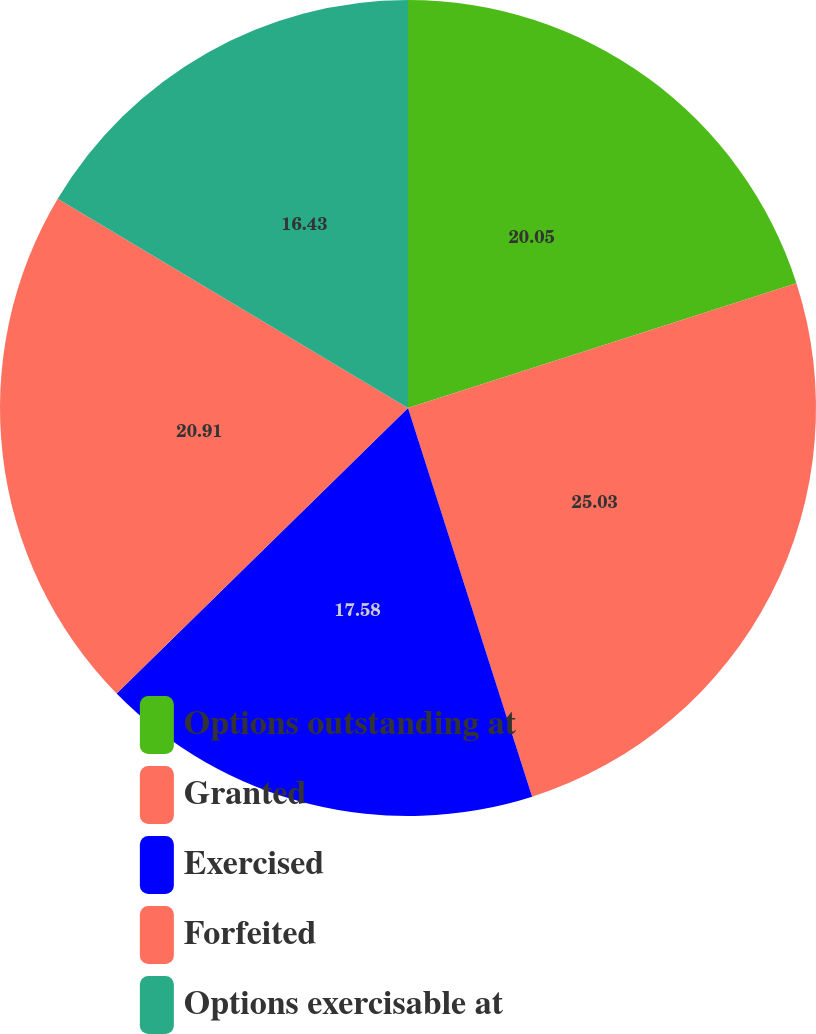Convert chart to OTSL. <chart><loc_0><loc_0><loc_500><loc_500><pie_chart><fcel>Options outstanding at<fcel>Granted<fcel>Exercised<fcel>Forfeited<fcel>Options exercisable at<nl><fcel>20.05%<fcel>25.03%<fcel>17.58%<fcel>20.91%<fcel>16.43%<nl></chart> 